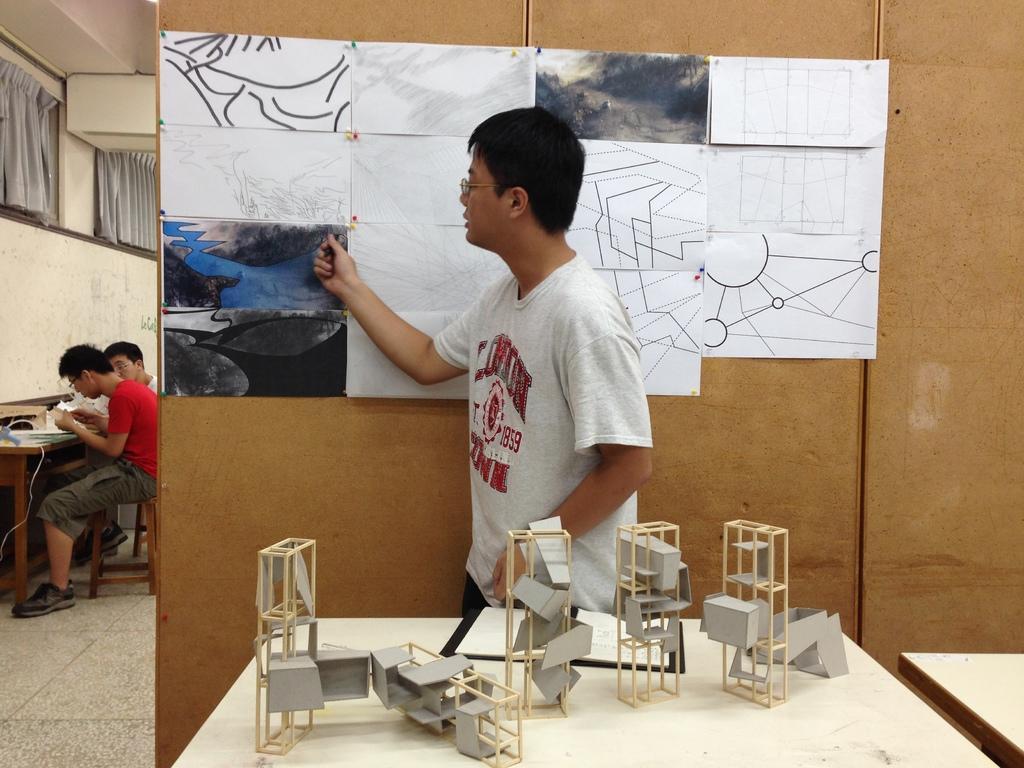Could you give a brief overview of what you see in this image? Here a person is standing at the table. On the wall there are paper posters. In the background there are 2 men sitting on the chair at the table. 